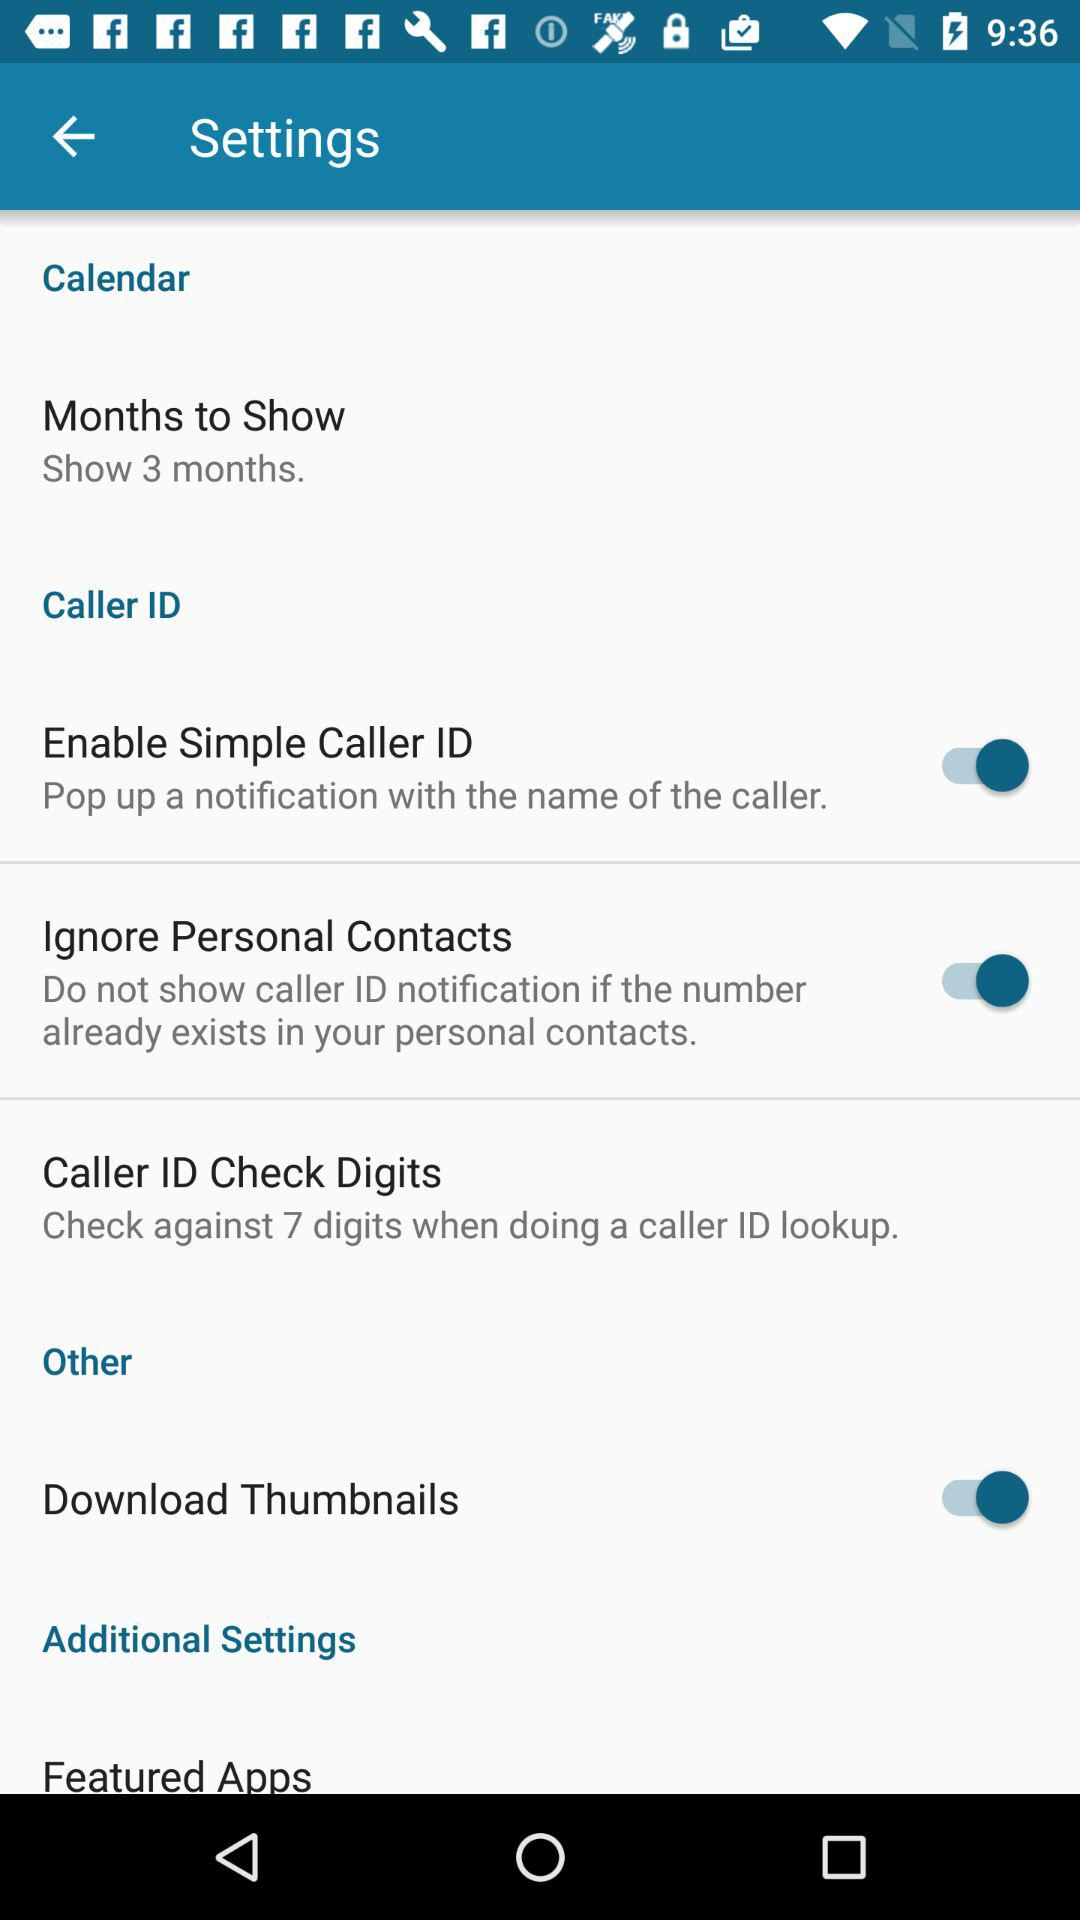How many settings options are available for Caller ID?
Answer the question using a single word or phrase. 3 